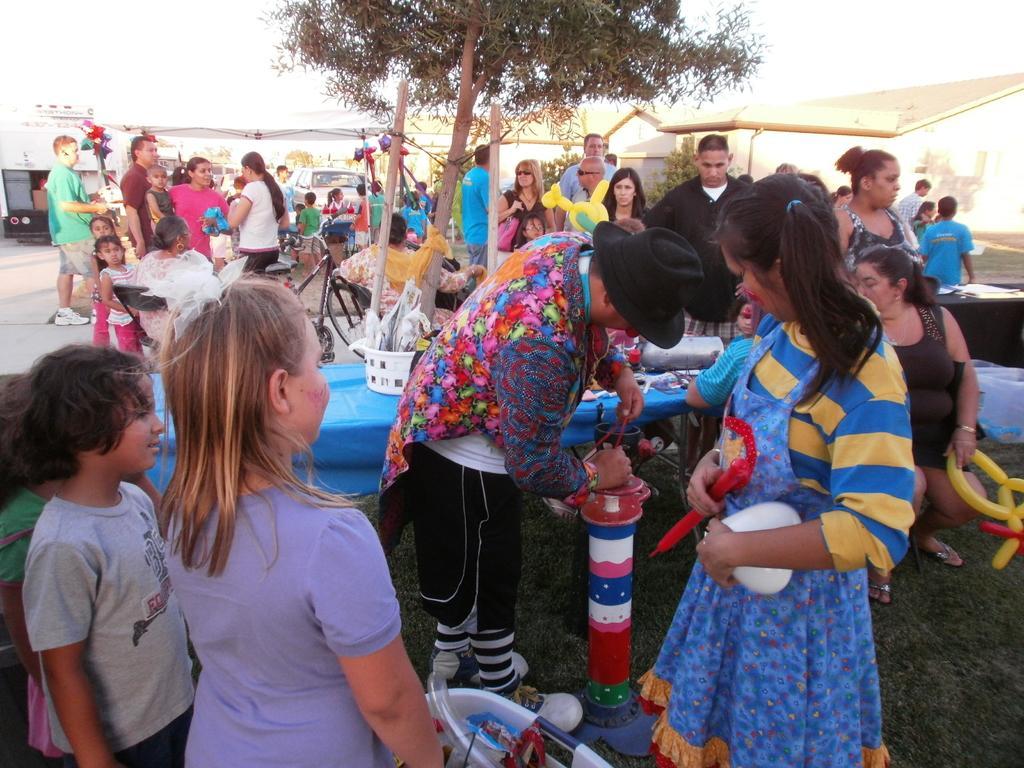In one or two sentences, can you explain what this image depicts? In this image in front there are people holding some objects. Behind them there is a table. On top of it there are a few objects. Behind the table there are people standing the road. In the background of the image there are trees, cars, buildings. 